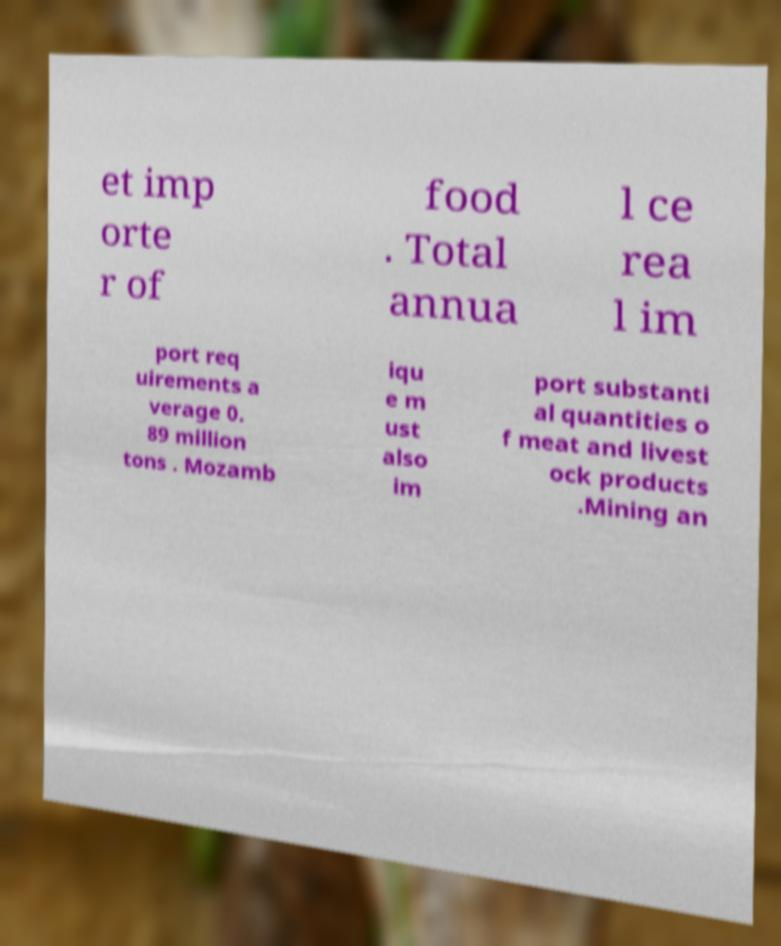Can you accurately transcribe the text from the provided image for me? et imp orte r of food . Total annua l ce rea l im port req uirements a verage 0. 89 million tons . Mozamb iqu e m ust also im port substanti al quantities o f meat and livest ock products .Mining an 